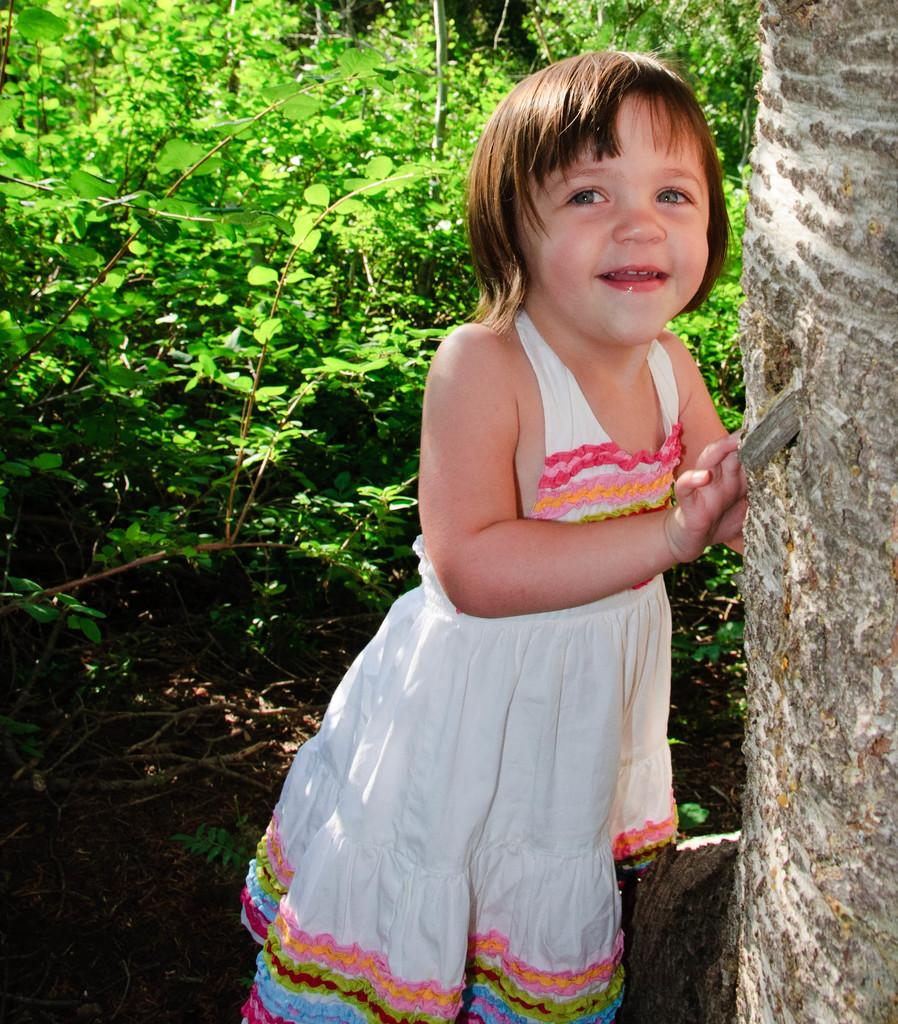Who is the main subject in the image? There is a small girl in the image. What is the girl doing in the image? The girl is standing beside a tree trunk. What can be seen in the background of the image? There are many plants visible behind the girl. What type of pizzas is the girl eating in the image? There is no pizza present in the image; the girl is standing beside a tree trunk with plants visible in the background. 